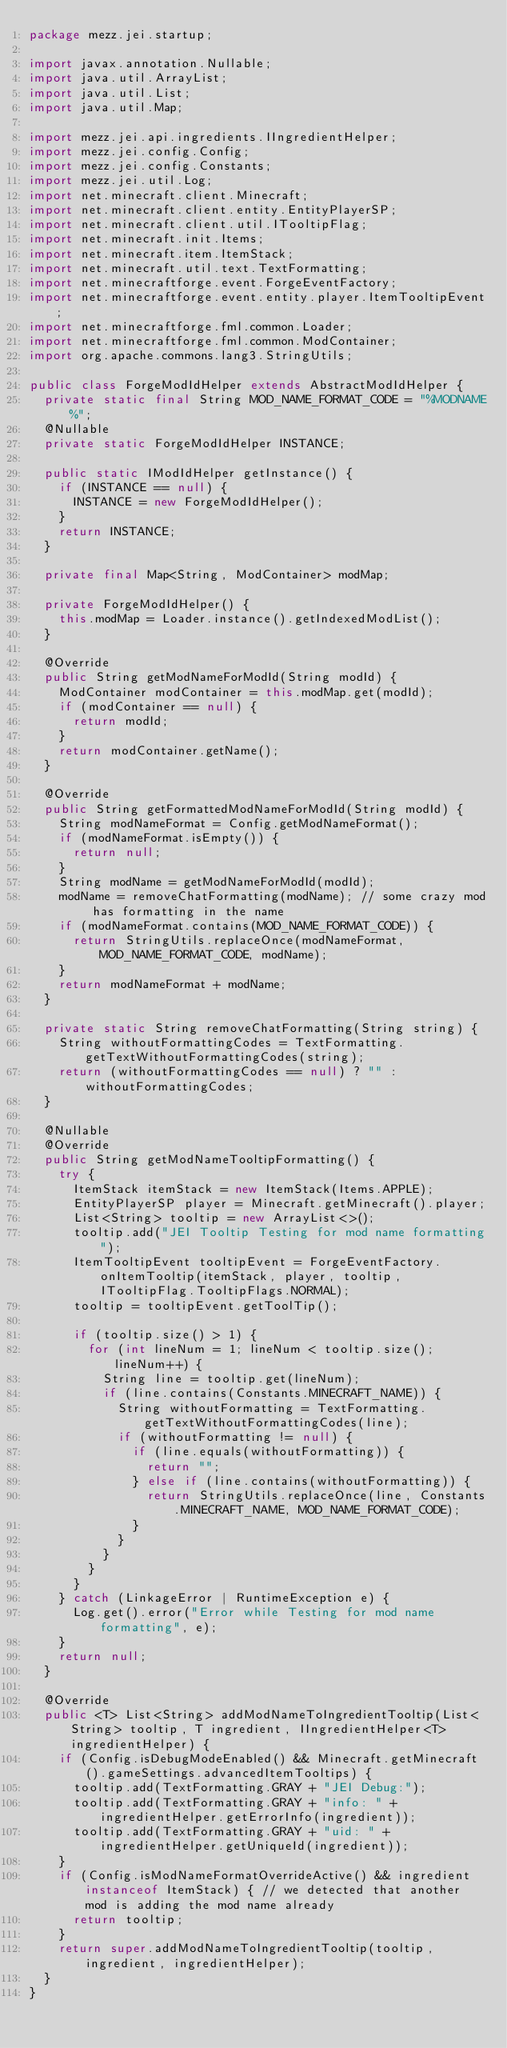<code> <loc_0><loc_0><loc_500><loc_500><_Java_>package mezz.jei.startup;

import javax.annotation.Nullable;
import java.util.ArrayList;
import java.util.List;
import java.util.Map;

import mezz.jei.api.ingredients.IIngredientHelper;
import mezz.jei.config.Config;
import mezz.jei.config.Constants;
import mezz.jei.util.Log;
import net.minecraft.client.Minecraft;
import net.minecraft.client.entity.EntityPlayerSP;
import net.minecraft.client.util.ITooltipFlag;
import net.minecraft.init.Items;
import net.minecraft.item.ItemStack;
import net.minecraft.util.text.TextFormatting;
import net.minecraftforge.event.ForgeEventFactory;
import net.minecraftforge.event.entity.player.ItemTooltipEvent;
import net.minecraftforge.fml.common.Loader;
import net.minecraftforge.fml.common.ModContainer;
import org.apache.commons.lang3.StringUtils;

public class ForgeModIdHelper extends AbstractModIdHelper {
	private static final String MOD_NAME_FORMAT_CODE = "%MODNAME%";
	@Nullable
	private static ForgeModIdHelper INSTANCE;

	public static IModIdHelper getInstance() {
		if (INSTANCE == null) {
			INSTANCE = new ForgeModIdHelper();
		}
		return INSTANCE;
	}

	private final Map<String, ModContainer> modMap;

	private ForgeModIdHelper() {
		this.modMap = Loader.instance().getIndexedModList();
	}

	@Override
	public String getModNameForModId(String modId) {
		ModContainer modContainer = this.modMap.get(modId);
		if (modContainer == null) {
			return modId;
		}
		return modContainer.getName();
	}

	@Override
	public String getFormattedModNameForModId(String modId) {
		String modNameFormat = Config.getModNameFormat();
		if (modNameFormat.isEmpty()) {
			return null;
		}
		String modName = getModNameForModId(modId);
		modName = removeChatFormatting(modName); // some crazy mod has formatting in the name
		if (modNameFormat.contains(MOD_NAME_FORMAT_CODE)) {
			return StringUtils.replaceOnce(modNameFormat, MOD_NAME_FORMAT_CODE, modName);
		}
		return modNameFormat + modName;
	}

	private static String removeChatFormatting(String string) {
		String withoutFormattingCodes = TextFormatting.getTextWithoutFormattingCodes(string);
		return (withoutFormattingCodes == null) ? "" : withoutFormattingCodes;
	}

	@Nullable
	@Override
	public String getModNameTooltipFormatting() {
		try {
			ItemStack itemStack = new ItemStack(Items.APPLE);
			EntityPlayerSP player = Minecraft.getMinecraft().player;
			List<String> tooltip = new ArrayList<>();
			tooltip.add("JEI Tooltip Testing for mod name formatting");
			ItemTooltipEvent tooltipEvent = ForgeEventFactory.onItemTooltip(itemStack, player, tooltip, ITooltipFlag.TooltipFlags.NORMAL);
			tooltip = tooltipEvent.getToolTip();

			if (tooltip.size() > 1) {
				for (int lineNum = 1; lineNum < tooltip.size(); lineNum++) {
					String line = tooltip.get(lineNum);
					if (line.contains(Constants.MINECRAFT_NAME)) {
						String withoutFormatting = TextFormatting.getTextWithoutFormattingCodes(line);
						if (withoutFormatting != null) {
							if (line.equals(withoutFormatting)) {
								return "";
							} else if (line.contains(withoutFormatting)) {
								return StringUtils.replaceOnce(line, Constants.MINECRAFT_NAME, MOD_NAME_FORMAT_CODE);
							}
						}
					}
				}
			}
		} catch (LinkageError | RuntimeException e) {
			Log.get().error("Error while Testing for mod name formatting", e);
		}
		return null;
	}

	@Override
	public <T> List<String> addModNameToIngredientTooltip(List<String> tooltip, T ingredient, IIngredientHelper<T> ingredientHelper) {
		if (Config.isDebugModeEnabled() && Minecraft.getMinecraft().gameSettings.advancedItemTooltips) {
			tooltip.add(TextFormatting.GRAY + "JEI Debug:");
			tooltip.add(TextFormatting.GRAY + "info: " + ingredientHelper.getErrorInfo(ingredient));
			tooltip.add(TextFormatting.GRAY + "uid: " + ingredientHelper.getUniqueId(ingredient));
		}
		if (Config.isModNameFormatOverrideActive() && ingredient instanceof ItemStack) { // we detected that another mod is adding the mod name already
			return tooltip;
		}
		return super.addModNameToIngredientTooltip(tooltip, ingredient, ingredientHelper);
	}
}
</code> 